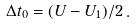Convert formula to latex. <formula><loc_0><loc_0><loc_500><loc_500>\Delta t _ { 0 } = ( U - U _ { 1 } ) / 2 \, .</formula> 